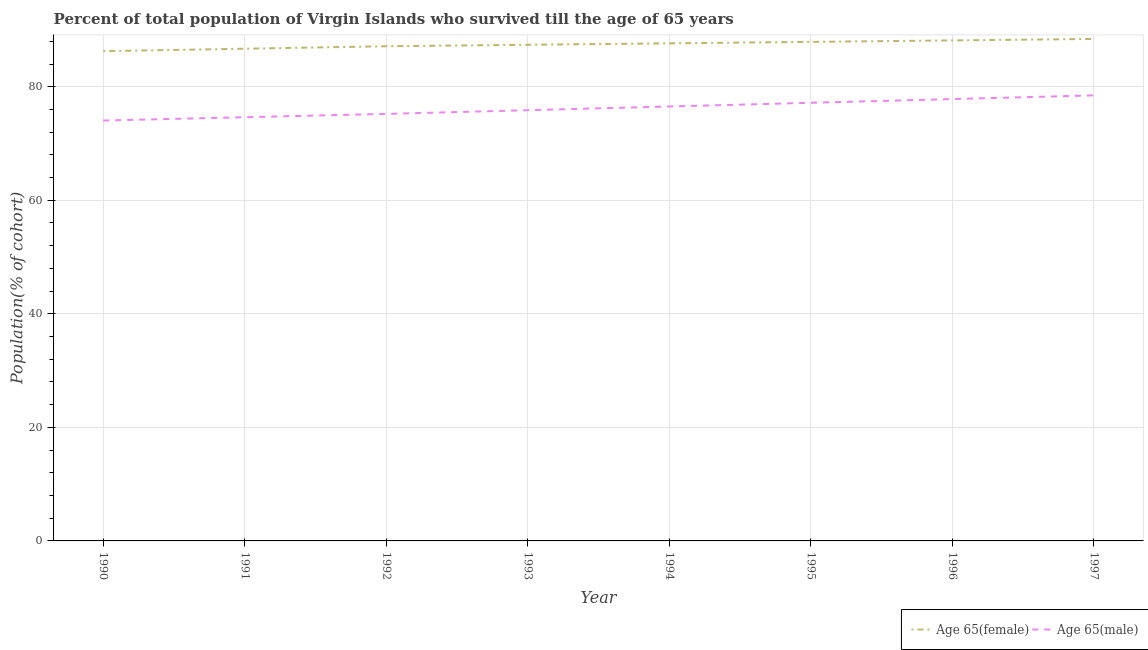How many different coloured lines are there?
Your answer should be compact. 2. What is the percentage of male population who survived till age of 65 in 1995?
Offer a terse response. 77.17. Across all years, what is the maximum percentage of female population who survived till age of 65?
Give a very brief answer. 88.41. Across all years, what is the minimum percentage of male population who survived till age of 65?
Provide a succinct answer. 74.04. In which year was the percentage of male population who survived till age of 65 maximum?
Keep it short and to the point. 1997. What is the total percentage of female population who survived till age of 65 in the graph?
Your answer should be compact. 699.58. What is the difference between the percentage of male population who survived till age of 65 in 1991 and that in 1992?
Your answer should be compact. -0.59. What is the difference between the percentage of female population who survived till age of 65 in 1993 and the percentage of male population who survived till age of 65 in 1990?
Provide a short and direct response. 13.34. What is the average percentage of male population who survived till age of 65 per year?
Your answer should be very brief. 76.22. In the year 1997, what is the difference between the percentage of male population who survived till age of 65 and percentage of female population who survived till age of 65?
Give a very brief answer. -9.94. In how many years, is the percentage of male population who survived till age of 65 greater than 36 %?
Provide a succinct answer. 8. What is the ratio of the percentage of female population who survived till age of 65 in 1992 to that in 1995?
Your answer should be compact. 0.99. Is the percentage of male population who survived till age of 65 in 1995 less than that in 1996?
Offer a very short reply. Yes. What is the difference between the highest and the second highest percentage of male population who survived till age of 65?
Offer a very short reply. 0.65. What is the difference between the highest and the lowest percentage of male population who survived till age of 65?
Your answer should be very brief. 4.43. In how many years, is the percentage of male population who survived till age of 65 greater than the average percentage of male population who survived till age of 65 taken over all years?
Offer a terse response. 4. Is the percentage of male population who survived till age of 65 strictly greater than the percentage of female population who survived till age of 65 over the years?
Your answer should be very brief. No. Is the percentage of male population who survived till age of 65 strictly less than the percentage of female population who survived till age of 65 over the years?
Provide a short and direct response. Yes. How many years are there in the graph?
Your response must be concise. 8. Does the graph contain any zero values?
Ensure brevity in your answer.  No. Where does the legend appear in the graph?
Your answer should be very brief. Bottom right. How many legend labels are there?
Provide a short and direct response. 2. What is the title of the graph?
Offer a very short reply. Percent of total population of Virgin Islands who survived till the age of 65 years. Does "Total Population" appear as one of the legend labels in the graph?
Give a very brief answer. No. What is the label or title of the Y-axis?
Your response must be concise. Population(% of cohort). What is the Population(% of cohort) in Age 65(female) in 1990?
Your answer should be compact. 86.26. What is the Population(% of cohort) in Age 65(male) in 1990?
Your response must be concise. 74.04. What is the Population(% of cohort) of Age 65(female) in 1991?
Your answer should be compact. 86.69. What is the Population(% of cohort) of Age 65(male) in 1991?
Your response must be concise. 74.63. What is the Population(% of cohort) in Age 65(female) in 1992?
Keep it short and to the point. 87.13. What is the Population(% of cohort) of Age 65(male) in 1992?
Your answer should be very brief. 75.21. What is the Population(% of cohort) in Age 65(female) in 1993?
Provide a short and direct response. 87.38. What is the Population(% of cohort) in Age 65(male) in 1993?
Keep it short and to the point. 75.87. What is the Population(% of cohort) of Age 65(female) in 1994?
Ensure brevity in your answer.  87.64. What is the Population(% of cohort) in Age 65(male) in 1994?
Give a very brief answer. 76.52. What is the Population(% of cohort) of Age 65(female) in 1995?
Your answer should be very brief. 87.9. What is the Population(% of cohort) of Age 65(male) in 1995?
Provide a succinct answer. 77.17. What is the Population(% of cohort) in Age 65(female) in 1996?
Your response must be concise. 88.16. What is the Population(% of cohort) in Age 65(male) in 1996?
Your answer should be compact. 77.82. What is the Population(% of cohort) of Age 65(female) in 1997?
Your answer should be compact. 88.41. What is the Population(% of cohort) of Age 65(male) in 1997?
Offer a very short reply. 78.48. Across all years, what is the maximum Population(% of cohort) in Age 65(female)?
Provide a short and direct response. 88.41. Across all years, what is the maximum Population(% of cohort) in Age 65(male)?
Your response must be concise. 78.48. Across all years, what is the minimum Population(% of cohort) of Age 65(female)?
Your answer should be compact. 86.26. Across all years, what is the minimum Population(% of cohort) of Age 65(male)?
Your answer should be very brief. 74.04. What is the total Population(% of cohort) of Age 65(female) in the graph?
Provide a succinct answer. 699.58. What is the total Population(% of cohort) of Age 65(male) in the graph?
Your answer should be compact. 609.74. What is the difference between the Population(% of cohort) in Age 65(female) in 1990 and that in 1991?
Offer a very short reply. -0.43. What is the difference between the Population(% of cohort) of Age 65(male) in 1990 and that in 1991?
Your answer should be compact. -0.59. What is the difference between the Population(% of cohort) of Age 65(female) in 1990 and that in 1992?
Your response must be concise. -0.87. What is the difference between the Population(% of cohort) of Age 65(male) in 1990 and that in 1992?
Ensure brevity in your answer.  -1.17. What is the difference between the Population(% of cohort) of Age 65(female) in 1990 and that in 1993?
Give a very brief answer. -1.12. What is the difference between the Population(% of cohort) of Age 65(male) in 1990 and that in 1993?
Keep it short and to the point. -1.82. What is the difference between the Population(% of cohort) in Age 65(female) in 1990 and that in 1994?
Keep it short and to the point. -1.38. What is the difference between the Population(% of cohort) of Age 65(male) in 1990 and that in 1994?
Your answer should be very brief. -2.48. What is the difference between the Population(% of cohort) of Age 65(female) in 1990 and that in 1995?
Make the answer very short. -1.64. What is the difference between the Population(% of cohort) of Age 65(male) in 1990 and that in 1995?
Offer a very short reply. -3.13. What is the difference between the Population(% of cohort) of Age 65(female) in 1990 and that in 1996?
Keep it short and to the point. -1.89. What is the difference between the Population(% of cohort) of Age 65(male) in 1990 and that in 1996?
Offer a very short reply. -3.78. What is the difference between the Population(% of cohort) of Age 65(female) in 1990 and that in 1997?
Provide a succinct answer. -2.15. What is the difference between the Population(% of cohort) in Age 65(male) in 1990 and that in 1997?
Your answer should be compact. -4.43. What is the difference between the Population(% of cohort) of Age 65(female) in 1991 and that in 1992?
Make the answer very short. -0.43. What is the difference between the Population(% of cohort) in Age 65(male) in 1991 and that in 1992?
Your answer should be very brief. -0.59. What is the difference between the Population(% of cohort) of Age 65(female) in 1991 and that in 1993?
Your answer should be very brief. -0.69. What is the difference between the Population(% of cohort) of Age 65(male) in 1991 and that in 1993?
Provide a succinct answer. -1.24. What is the difference between the Population(% of cohort) in Age 65(female) in 1991 and that in 1994?
Provide a short and direct response. -0.95. What is the difference between the Population(% of cohort) of Age 65(male) in 1991 and that in 1994?
Your answer should be compact. -1.89. What is the difference between the Population(% of cohort) of Age 65(female) in 1991 and that in 1995?
Your answer should be compact. -1.2. What is the difference between the Population(% of cohort) in Age 65(male) in 1991 and that in 1995?
Your response must be concise. -2.54. What is the difference between the Population(% of cohort) of Age 65(female) in 1991 and that in 1996?
Ensure brevity in your answer.  -1.46. What is the difference between the Population(% of cohort) of Age 65(male) in 1991 and that in 1996?
Give a very brief answer. -3.2. What is the difference between the Population(% of cohort) of Age 65(female) in 1991 and that in 1997?
Offer a very short reply. -1.72. What is the difference between the Population(% of cohort) in Age 65(male) in 1991 and that in 1997?
Offer a terse response. -3.85. What is the difference between the Population(% of cohort) of Age 65(female) in 1992 and that in 1993?
Provide a succinct answer. -0.26. What is the difference between the Population(% of cohort) in Age 65(male) in 1992 and that in 1993?
Offer a terse response. -0.65. What is the difference between the Population(% of cohort) of Age 65(female) in 1992 and that in 1994?
Give a very brief answer. -0.51. What is the difference between the Population(% of cohort) of Age 65(male) in 1992 and that in 1994?
Provide a short and direct response. -1.31. What is the difference between the Population(% of cohort) in Age 65(female) in 1992 and that in 1995?
Offer a very short reply. -0.77. What is the difference between the Population(% of cohort) in Age 65(male) in 1992 and that in 1995?
Your response must be concise. -1.96. What is the difference between the Population(% of cohort) in Age 65(female) in 1992 and that in 1996?
Your answer should be very brief. -1.03. What is the difference between the Population(% of cohort) of Age 65(male) in 1992 and that in 1996?
Your response must be concise. -2.61. What is the difference between the Population(% of cohort) in Age 65(female) in 1992 and that in 1997?
Ensure brevity in your answer.  -1.28. What is the difference between the Population(% of cohort) in Age 65(male) in 1992 and that in 1997?
Keep it short and to the point. -3.26. What is the difference between the Population(% of cohort) in Age 65(female) in 1993 and that in 1994?
Your answer should be very brief. -0.26. What is the difference between the Population(% of cohort) of Age 65(male) in 1993 and that in 1994?
Your answer should be very brief. -0.65. What is the difference between the Population(% of cohort) in Age 65(female) in 1993 and that in 1995?
Keep it short and to the point. -0.51. What is the difference between the Population(% of cohort) in Age 65(male) in 1993 and that in 1995?
Keep it short and to the point. -1.31. What is the difference between the Population(% of cohort) in Age 65(female) in 1993 and that in 1996?
Make the answer very short. -0.77. What is the difference between the Population(% of cohort) of Age 65(male) in 1993 and that in 1996?
Give a very brief answer. -1.96. What is the difference between the Population(% of cohort) of Age 65(female) in 1993 and that in 1997?
Your response must be concise. -1.03. What is the difference between the Population(% of cohort) of Age 65(male) in 1993 and that in 1997?
Provide a succinct answer. -2.61. What is the difference between the Population(% of cohort) in Age 65(female) in 1994 and that in 1995?
Provide a succinct answer. -0.26. What is the difference between the Population(% of cohort) of Age 65(male) in 1994 and that in 1995?
Ensure brevity in your answer.  -0.65. What is the difference between the Population(% of cohort) in Age 65(female) in 1994 and that in 1996?
Provide a succinct answer. -0.51. What is the difference between the Population(% of cohort) of Age 65(male) in 1994 and that in 1996?
Make the answer very short. -1.31. What is the difference between the Population(% of cohort) in Age 65(female) in 1994 and that in 1997?
Provide a succinct answer. -0.77. What is the difference between the Population(% of cohort) in Age 65(male) in 1994 and that in 1997?
Offer a terse response. -1.96. What is the difference between the Population(% of cohort) of Age 65(female) in 1995 and that in 1996?
Your response must be concise. -0.26. What is the difference between the Population(% of cohort) of Age 65(male) in 1995 and that in 1996?
Provide a succinct answer. -0.65. What is the difference between the Population(% of cohort) in Age 65(female) in 1995 and that in 1997?
Keep it short and to the point. -0.51. What is the difference between the Population(% of cohort) in Age 65(male) in 1995 and that in 1997?
Offer a terse response. -1.31. What is the difference between the Population(% of cohort) of Age 65(female) in 1996 and that in 1997?
Give a very brief answer. -0.26. What is the difference between the Population(% of cohort) in Age 65(male) in 1996 and that in 1997?
Offer a very short reply. -0.65. What is the difference between the Population(% of cohort) in Age 65(female) in 1990 and the Population(% of cohort) in Age 65(male) in 1991?
Your response must be concise. 11.63. What is the difference between the Population(% of cohort) of Age 65(female) in 1990 and the Population(% of cohort) of Age 65(male) in 1992?
Your answer should be very brief. 11.05. What is the difference between the Population(% of cohort) in Age 65(female) in 1990 and the Population(% of cohort) in Age 65(male) in 1993?
Your response must be concise. 10.4. What is the difference between the Population(% of cohort) in Age 65(female) in 1990 and the Population(% of cohort) in Age 65(male) in 1994?
Provide a short and direct response. 9.74. What is the difference between the Population(% of cohort) of Age 65(female) in 1990 and the Population(% of cohort) of Age 65(male) in 1995?
Provide a short and direct response. 9.09. What is the difference between the Population(% of cohort) in Age 65(female) in 1990 and the Population(% of cohort) in Age 65(male) in 1996?
Your answer should be very brief. 8.44. What is the difference between the Population(% of cohort) of Age 65(female) in 1990 and the Population(% of cohort) of Age 65(male) in 1997?
Give a very brief answer. 7.78. What is the difference between the Population(% of cohort) of Age 65(female) in 1991 and the Population(% of cohort) of Age 65(male) in 1992?
Your answer should be compact. 11.48. What is the difference between the Population(% of cohort) of Age 65(female) in 1991 and the Population(% of cohort) of Age 65(male) in 1993?
Make the answer very short. 10.83. What is the difference between the Population(% of cohort) of Age 65(female) in 1991 and the Population(% of cohort) of Age 65(male) in 1994?
Give a very brief answer. 10.18. What is the difference between the Population(% of cohort) in Age 65(female) in 1991 and the Population(% of cohort) in Age 65(male) in 1995?
Give a very brief answer. 9.52. What is the difference between the Population(% of cohort) in Age 65(female) in 1991 and the Population(% of cohort) in Age 65(male) in 1996?
Give a very brief answer. 8.87. What is the difference between the Population(% of cohort) of Age 65(female) in 1991 and the Population(% of cohort) of Age 65(male) in 1997?
Your answer should be very brief. 8.22. What is the difference between the Population(% of cohort) of Age 65(female) in 1992 and the Population(% of cohort) of Age 65(male) in 1993?
Make the answer very short. 11.26. What is the difference between the Population(% of cohort) in Age 65(female) in 1992 and the Population(% of cohort) in Age 65(male) in 1994?
Provide a short and direct response. 10.61. What is the difference between the Population(% of cohort) of Age 65(female) in 1992 and the Population(% of cohort) of Age 65(male) in 1995?
Offer a very short reply. 9.96. What is the difference between the Population(% of cohort) of Age 65(female) in 1992 and the Population(% of cohort) of Age 65(male) in 1996?
Keep it short and to the point. 9.3. What is the difference between the Population(% of cohort) in Age 65(female) in 1992 and the Population(% of cohort) in Age 65(male) in 1997?
Your answer should be compact. 8.65. What is the difference between the Population(% of cohort) of Age 65(female) in 1993 and the Population(% of cohort) of Age 65(male) in 1994?
Your answer should be very brief. 10.87. What is the difference between the Population(% of cohort) in Age 65(female) in 1993 and the Population(% of cohort) in Age 65(male) in 1995?
Your answer should be compact. 10.21. What is the difference between the Population(% of cohort) in Age 65(female) in 1993 and the Population(% of cohort) in Age 65(male) in 1996?
Ensure brevity in your answer.  9.56. What is the difference between the Population(% of cohort) in Age 65(female) in 1993 and the Population(% of cohort) in Age 65(male) in 1997?
Give a very brief answer. 8.91. What is the difference between the Population(% of cohort) of Age 65(female) in 1994 and the Population(% of cohort) of Age 65(male) in 1995?
Ensure brevity in your answer.  10.47. What is the difference between the Population(% of cohort) of Age 65(female) in 1994 and the Population(% of cohort) of Age 65(male) in 1996?
Offer a very short reply. 9.82. What is the difference between the Population(% of cohort) in Age 65(female) in 1994 and the Population(% of cohort) in Age 65(male) in 1997?
Your response must be concise. 9.17. What is the difference between the Population(% of cohort) of Age 65(female) in 1995 and the Population(% of cohort) of Age 65(male) in 1996?
Offer a very short reply. 10.07. What is the difference between the Population(% of cohort) of Age 65(female) in 1995 and the Population(% of cohort) of Age 65(male) in 1997?
Your answer should be compact. 9.42. What is the difference between the Population(% of cohort) of Age 65(female) in 1996 and the Population(% of cohort) of Age 65(male) in 1997?
Offer a terse response. 9.68. What is the average Population(% of cohort) of Age 65(female) per year?
Make the answer very short. 87.45. What is the average Population(% of cohort) in Age 65(male) per year?
Ensure brevity in your answer.  76.22. In the year 1990, what is the difference between the Population(% of cohort) in Age 65(female) and Population(% of cohort) in Age 65(male)?
Your answer should be compact. 12.22. In the year 1991, what is the difference between the Population(% of cohort) in Age 65(female) and Population(% of cohort) in Age 65(male)?
Your answer should be compact. 12.07. In the year 1992, what is the difference between the Population(% of cohort) of Age 65(female) and Population(% of cohort) of Age 65(male)?
Make the answer very short. 11.91. In the year 1993, what is the difference between the Population(% of cohort) in Age 65(female) and Population(% of cohort) in Age 65(male)?
Ensure brevity in your answer.  11.52. In the year 1994, what is the difference between the Population(% of cohort) of Age 65(female) and Population(% of cohort) of Age 65(male)?
Provide a succinct answer. 11.12. In the year 1995, what is the difference between the Population(% of cohort) of Age 65(female) and Population(% of cohort) of Age 65(male)?
Your response must be concise. 10.73. In the year 1996, what is the difference between the Population(% of cohort) of Age 65(female) and Population(% of cohort) of Age 65(male)?
Provide a succinct answer. 10.33. In the year 1997, what is the difference between the Population(% of cohort) of Age 65(female) and Population(% of cohort) of Age 65(male)?
Provide a short and direct response. 9.94. What is the ratio of the Population(% of cohort) in Age 65(female) in 1990 to that in 1991?
Offer a very short reply. 0.99. What is the ratio of the Population(% of cohort) in Age 65(male) in 1990 to that in 1991?
Offer a very short reply. 0.99. What is the ratio of the Population(% of cohort) of Age 65(male) in 1990 to that in 1992?
Give a very brief answer. 0.98. What is the ratio of the Population(% of cohort) of Age 65(female) in 1990 to that in 1993?
Give a very brief answer. 0.99. What is the ratio of the Population(% of cohort) in Age 65(male) in 1990 to that in 1993?
Provide a succinct answer. 0.98. What is the ratio of the Population(% of cohort) in Age 65(female) in 1990 to that in 1994?
Provide a short and direct response. 0.98. What is the ratio of the Population(% of cohort) of Age 65(male) in 1990 to that in 1994?
Make the answer very short. 0.97. What is the ratio of the Population(% of cohort) of Age 65(female) in 1990 to that in 1995?
Provide a succinct answer. 0.98. What is the ratio of the Population(% of cohort) of Age 65(male) in 1990 to that in 1995?
Your answer should be very brief. 0.96. What is the ratio of the Population(% of cohort) in Age 65(female) in 1990 to that in 1996?
Offer a very short reply. 0.98. What is the ratio of the Population(% of cohort) in Age 65(male) in 1990 to that in 1996?
Your answer should be very brief. 0.95. What is the ratio of the Population(% of cohort) in Age 65(female) in 1990 to that in 1997?
Give a very brief answer. 0.98. What is the ratio of the Population(% of cohort) in Age 65(male) in 1990 to that in 1997?
Ensure brevity in your answer.  0.94. What is the ratio of the Population(% of cohort) of Age 65(female) in 1991 to that in 1992?
Ensure brevity in your answer.  0.99. What is the ratio of the Population(% of cohort) of Age 65(male) in 1991 to that in 1993?
Make the answer very short. 0.98. What is the ratio of the Population(% of cohort) in Age 65(female) in 1991 to that in 1994?
Offer a terse response. 0.99. What is the ratio of the Population(% of cohort) in Age 65(male) in 1991 to that in 1994?
Provide a short and direct response. 0.98. What is the ratio of the Population(% of cohort) of Age 65(female) in 1991 to that in 1995?
Your response must be concise. 0.99. What is the ratio of the Population(% of cohort) of Age 65(female) in 1991 to that in 1996?
Offer a terse response. 0.98. What is the ratio of the Population(% of cohort) of Age 65(male) in 1991 to that in 1996?
Your response must be concise. 0.96. What is the ratio of the Population(% of cohort) in Age 65(female) in 1991 to that in 1997?
Your response must be concise. 0.98. What is the ratio of the Population(% of cohort) of Age 65(male) in 1991 to that in 1997?
Offer a very short reply. 0.95. What is the ratio of the Population(% of cohort) in Age 65(female) in 1992 to that in 1994?
Give a very brief answer. 0.99. What is the ratio of the Population(% of cohort) in Age 65(male) in 1992 to that in 1994?
Provide a short and direct response. 0.98. What is the ratio of the Population(% of cohort) in Age 65(male) in 1992 to that in 1995?
Keep it short and to the point. 0.97. What is the ratio of the Population(% of cohort) of Age 65(female) in 1992 to that in 1996?
Offer a terse response. 0.99. What is the ratio of the Population(% of cohort) of Age 65(male) in 1992 to that in 1996?
Ensure brevity in your answer.  0.97. What is the ratio of the Population(% of cohort) of Age 65(female) in 1992 to that in 1997?
Give a very brief answer. 0.99. What is the ratio of the Population(% of cohort) of Age 65(male) in 1992 to that in 1997?
Your answer should be compact. 0.96. What is the ratio of the Population(% of cohort) of Age 65(male) in 1993 to that in 1995?
Your answer should be compact. 0.98. What is the ratio of the Population(% of cohort) in Age 65(female) in 1993 to that in 1996?
Your answer should be compact. 0.99. What is the ratio of the Population(% of cohort) in Age 65(male) in 1993 to that in 1996?
Ensure brevity in your answer.  0.97. What is the ratio of the Population(% of cohort) of Age 65(female) in 1993 to that in 1997?
Your answer should be compact. 0.99. What is the ratio of the Population(% of cohort) of Age 65(male) in 1993 to that in 1997?
Ensure brevity in your answer.  0.97. What is the ratio of the Population(% of cohort) in Age 65(female) in 1994 to that in 1995?
Your response must be concise. 1. What is the ratio of the Population(% of cohort) of Age 65(female) in 1994 to that in 1996?
Provide a short and direct response. 0.99. What is the ratio of the Population(% of cohort) of Age 65(male) in 1994 to that in 1996?
Your answer should be compact. 0.98. What is the ratio of the Population(% of cohort) of Age 65(female) in 1994 to that in 1997?
Give a very brief answer. 0.99. What is the ratio of the Population(% of cohort) in Age 65(male) in 1994 to that in 1997?
Provide a succinct answer. 0.98. What is the ratio of the Population(% of cohort) in Age 65(male) in 1995 to that in 1996?
Your answer should be compact. 0.99. What is the ratio of the Population(% of cohort) of Age 65(female) in 1995 to that in 1997?
Ensure brevity in your answer.  0.99. What is the ratio of the Population(% of cohort) of Age 65(male) in 1995 to that in 1997?
Your response must be concise. 0.98. What is the ratio of the Population(% of cohort) in Age 65(male) in 1996 to that in 1997?
Provide a short and direct response. 0.99. What is the difference between the highest and the second highest Population(% of cohort) in Age 65(female)?
Keep it short and to the point. 0.26. What is the difference between the highest and the second highest Population(% of cohort) in Age 65(male)?
Keep it short and to the point. 0.65. What is the difference between the highest and the lowest Population(% of cohort) of Age 65(female)?
Provide a short and direct response. 2.15. What is the difference between the highest and the lowest Population(% of cohort) of Age 65(male)?
Provide a short and direct response. 4.43. 